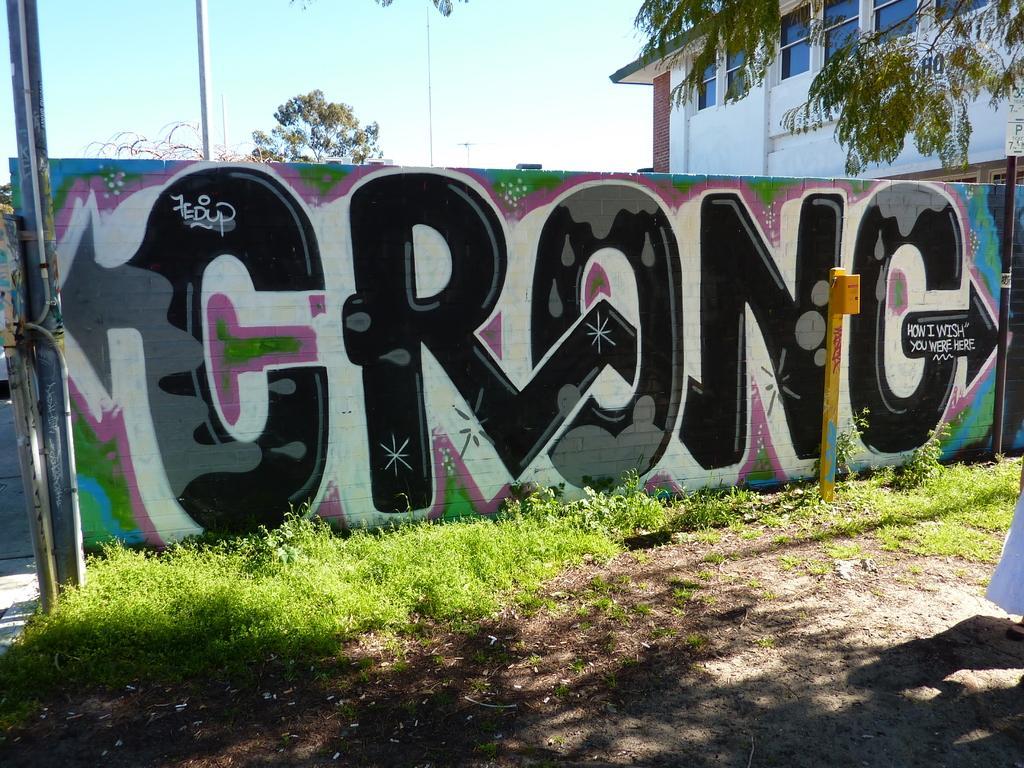How would you summarize this image in a sentence or two? In this image I can see grass, shadows, few poles, few trees, a building, the sky and here on this wall I can see a painting. 